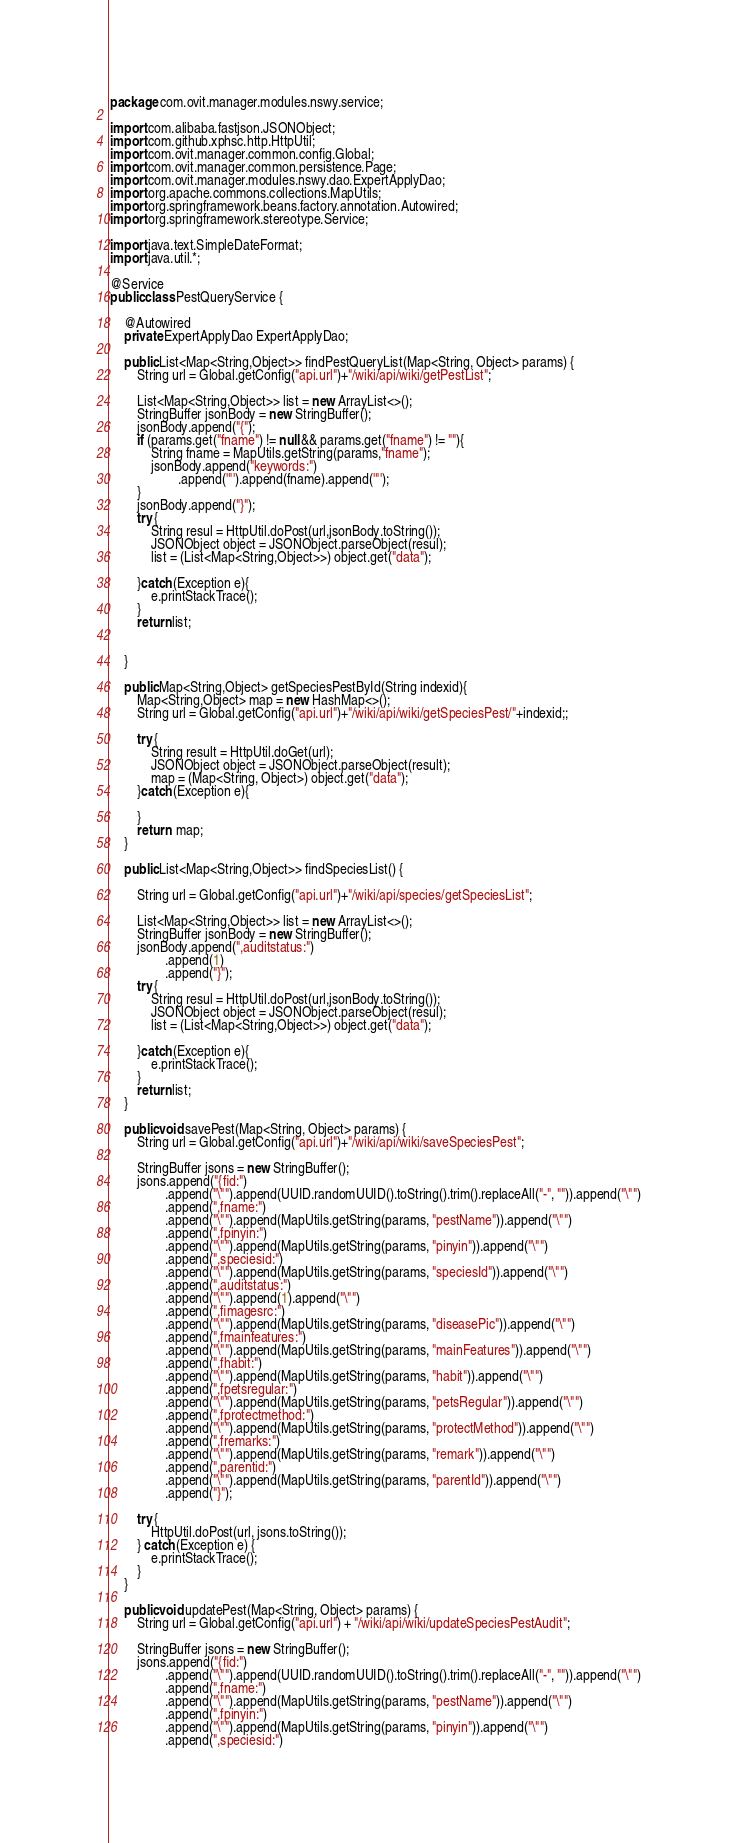<code> <loc_0><loc_0><loc_500><loc_500><_Java_>package com.ovit.manager.modules.nswy.service;

import com.alibaba.fastjson.JSONObject;
import com.github.xphsc.http.HttpUtil;
import com.ovit.manager.common.config.Global;
import com.ovit.manager.common.persistence.Page;
import com.ovit.manager.modules.nswy.dao.ExpertApplyDao;
import org.apache.commons.collections.MapUtils;
import org.springframework.beans.factory.annotation.Autowired;
import org.springframework.stereotype.Service;

import java.text.SimpleDateFormat;
import java.util.*;

@Service
public class PestQueryService {

    @Autowired
    private ExpertApplyDao ExpertApplyDao;

    public List<Map<String,Object>> findPestQueryList(Map<String, Object> params) {
        String url = Global.getConfig("api.url")+"/wiki/api/wiki/getPestList";

        List<Map<String,Object>> list = new ArrayList<>();
        StringBuffer jsonBody = new StringBuffer();
        jsonBody.append("{");
        if (params.get("fname") != null && params.get("fname") != ""){
            String fname = MapUtils.getString(params,"fname");
            jsonBody.append("keywords:")
                    .append('"').append(fname).append('"');
        }
        jsonBody.append("}");
        try {
            String resul = HttpUtil.doPost(url,jsonBody.toString());
            JSONObject object = JSONObject.parseObject(resul);
            list = (List<Map<String,Object>>) object.get("data");

        }catch (Exception e){
            e.printStackTrace();
        }
        return list;


    }

    public Map<String,Object> getSpeciesPestById(String indexid){
        Map<String,Object> map = new HashMap<>();
        String url = Global.getConfig("api.url")+"/wiki/api/wiki/getSpeciesPest/"+indexid;;

        try {
            String result = HttpUtil.doGet(url);
            JSONObject object = JSONObject.parseObject(result);
            map = (Map<String, Object>) object.get("data");
        }catch (Exception e){

        }
        return  map;
    }

    public List<Map<String,Object>> findSpeciesList() {

        String url = Global.getConfig("api.url")+"/wiki/api/species/getSpeciesList";

        List<Map<String,Object>> list = new ArrayList<>();
        StringBuffer jsonBody = new StringBuffer();
        jsonBody.append(",auditstatus:")
                .append(1)
                .append("}");
        try {
            String resul = HttpUtil.doPost(url,jsonBody.toString());
            JSONObject object = JSONObject.parseObject(resul);
            list = (List<Map<String,Object>>) object.get("data");

        }catch (Exception e){
            e.printStackTrace();
        }
        return list;
    }

    public void savePest(Map<String, Object> params) {
        String url = Global.getConfig("api.url")+"/wiki/api/wiki/saveSpeciesPest";

        StringBuffer jsons = new StringBuffer();
        jsons.append("{fid:")
                .append("\"").append(UUID.randomUUID().toString().trim().replaceAll("-", "")).append("\"")
                .append(",fname:")
                .append("\"").append(MapUtils.getString(params, "pestName")).append("\"")
                .append(",fpinyin:")
                .append("\"").append(MapUtils.getString(params, "pinyin")).append("\"")
                .append(",speciesid:")
                .append("\"").append(MapUtils.getString(params, "speciesId")).append("\"")
                .append(",auditstatus:")
                .append("\"").append(1).append("\"")
                .append(",fimagesrc:")
                .append("\"").append(MapUtils.getString(params, "diseasePic")).append("\"")
                .append(",fmainfeatures:")
                .append("\"").append(MapUtils.getString(params, "mainFeatures")).append("\"")
                .append(",fhabit:")
                .append("\"").append(MapUtils.getString(params, "habit")).append("\"")
                .append(",fpetsregular:")
                .append("\"").append(MapUtils.getString(params, "petsRegular")).append("\"")
                .append(",fprotectmethod:")
                .append("\"").append(MapUtils.getString(params, "protectMethod")).append("\"")
                .append(",fremarks:")
                .append("\"").append(MapUtils.getString(params, "remark")).append("\"")
                .append(",parentid:")
                .append("\"").append(MapUtils.getString(params, "parentId")).append("\"")
                .append("}");

        try {
            HttpUtil.doPost(url, jsons.toString());
        } catch (Exception e) {
            e.printStackTrace();
        }
    }

    public void updatePest(Map<String, Object> params) {
        String url = Global.getConfig("api.url") + "/wiki/api/wiki/updateSpeciesPestAudit";

        StringBuffer jsons = new StringBuffer();
        jsons.append("{fid:")
                .append("\"").append(UUID.randomUUID().toString().trim().replaceAll("-", "")).append("\"")
                .append(",fname:")
                .append("\"").append(MapUtils.getString(params, "pestName")).append("\"")
                .append(",fpinyin:")
                .append("\"").append(MapUtils.getString(params, "pinyin")).append("\"")
                .append(",speciesid:")</code> 